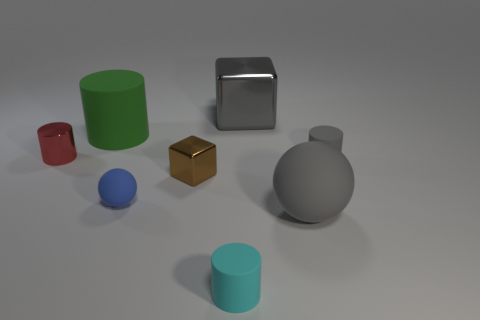Subtract all brown cylinders. Subtract all brown spheres. How many cylinders are left? 4 Add 1 big gray objects. How many objects exist? 9 Subtract all balls. How many objects are left? 6 Add 4 gray shiny things. How many gray shiny things are left? 5 Add 8 large gray spheres. How many large gray spheres exist? 9 Subtract 0 yellow cubes. How many objects are left? 8 Subtract all gray rubber balls. Subtract all big green things. How many objects are left? 6 